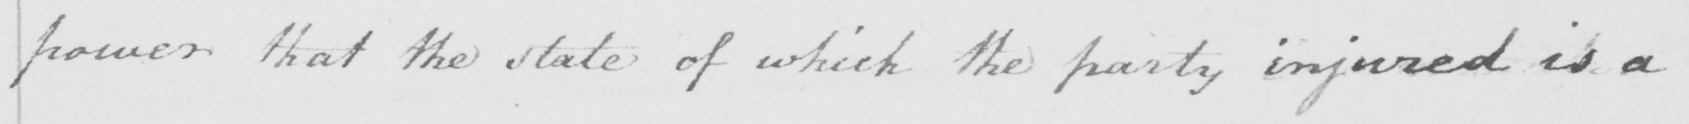Can you tell me what this handwritten text says? power that the state of which the party injured is a 